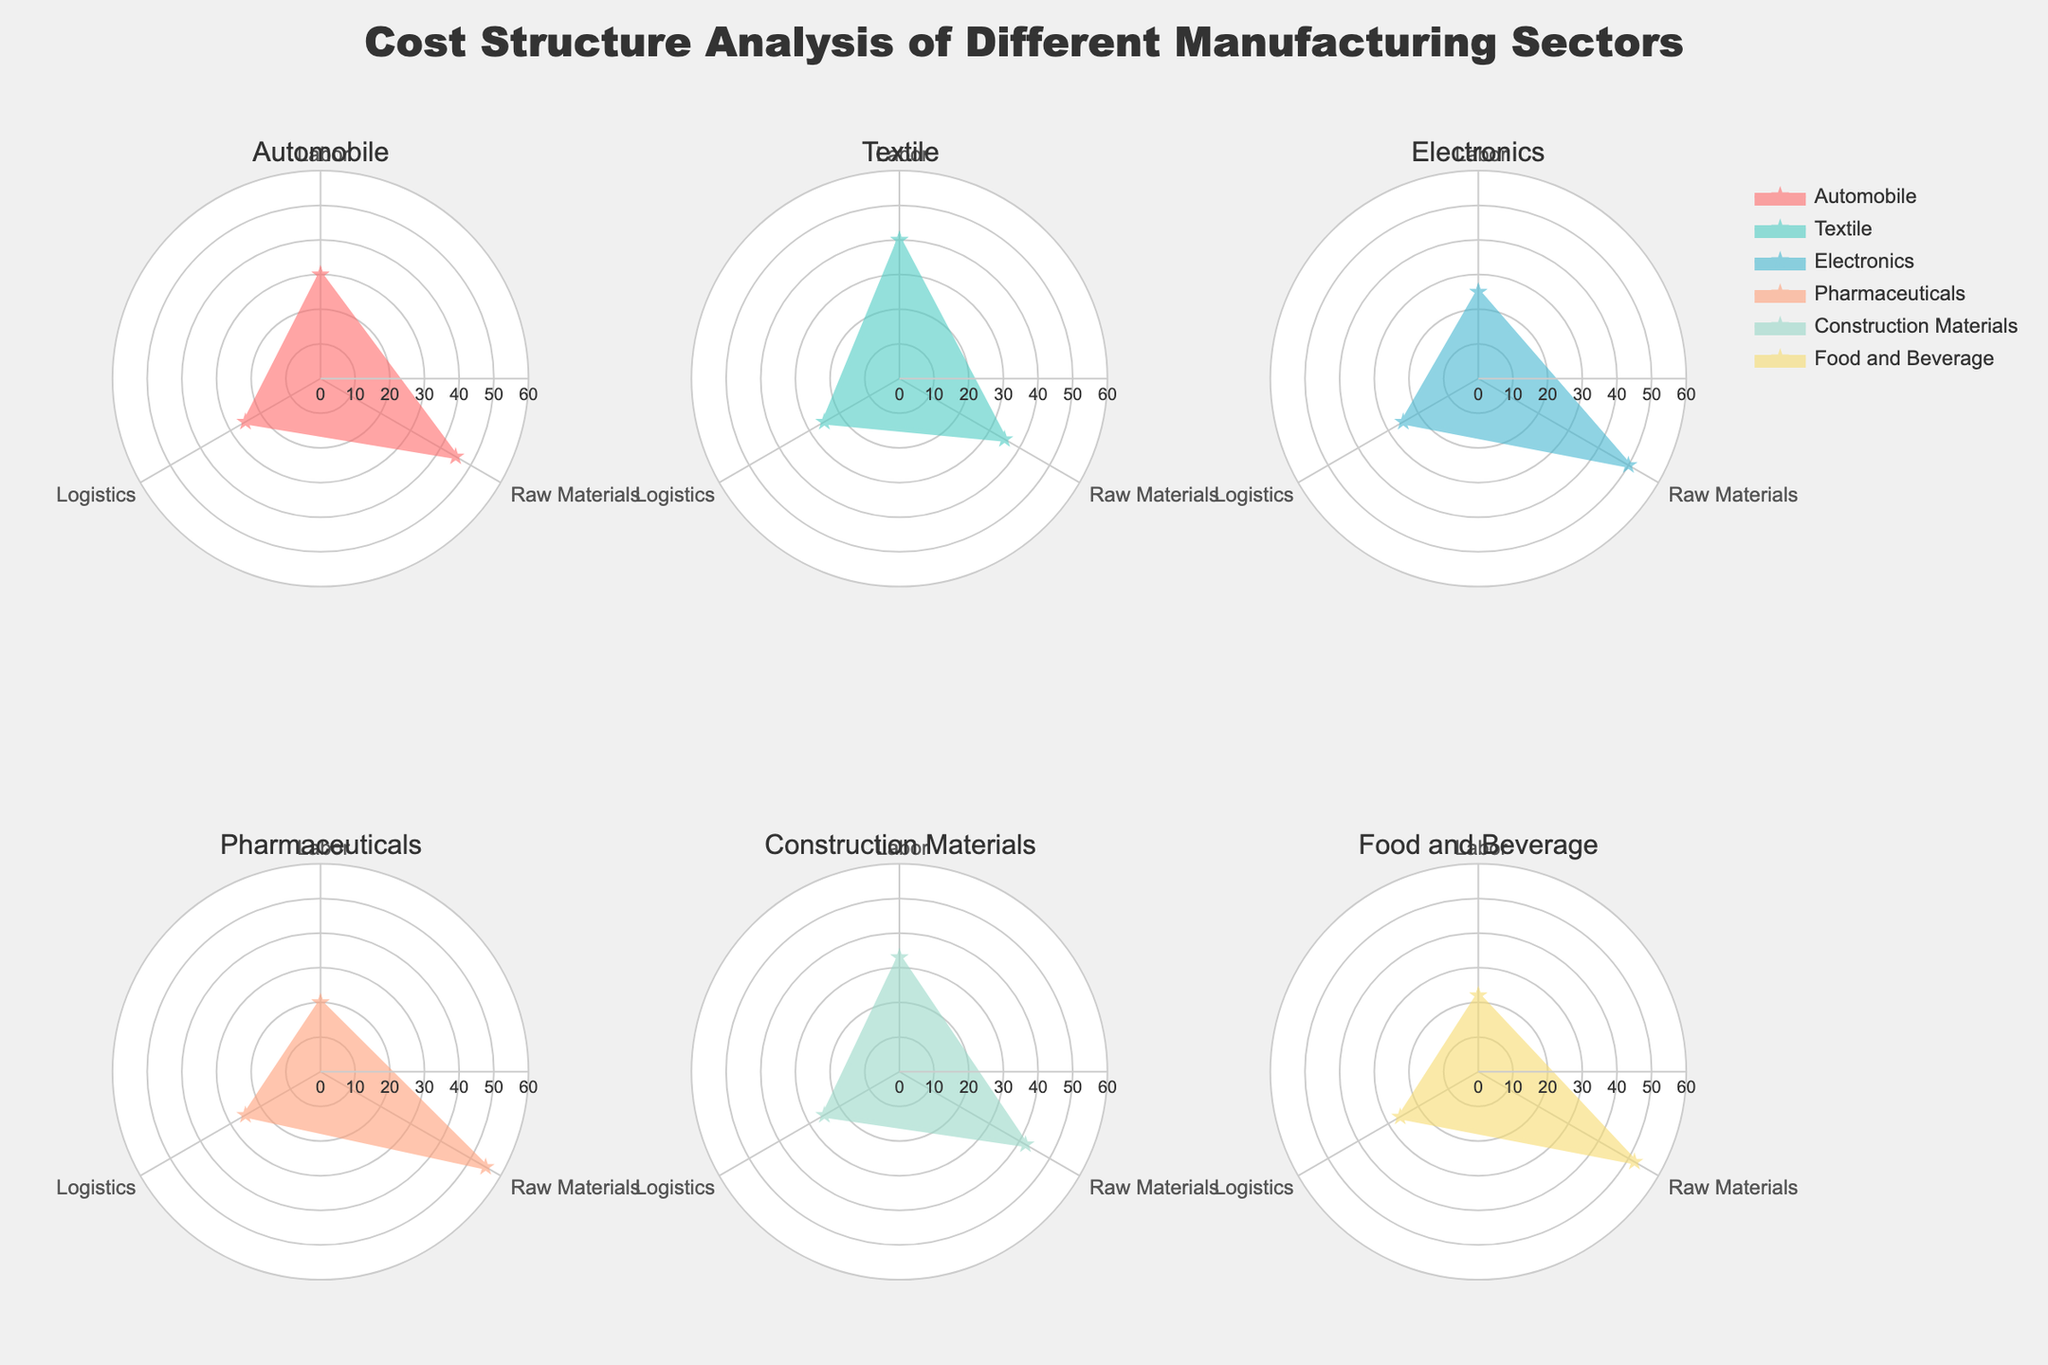Which sector has the highest cost percentage allocated to labor? By referring to the plotted data, the sector with the highest labor allocation is Textile with 40%. This can be determined by visually inspecting the labor percentage for each sector and finding the maximum value.
Answer: Textile Which two sectors have the same logistics cost percentage? By analyzing the logistics percentages in the radar charts, it can be observed that multiple sectors share the same logistics percentage. For instance, the sectors for Pharmaceuticals, Electronics, Automobile, and Textile have an identical logistics cost of 25%.
Answer: Pharmaceuticals, Electronics, Automobile, Textile What is the difference in raw material costs between Pharmaceuticals and Textile sectors? The raw material cost for Pharmaceuticals is 55%, and for Textile, it is 35%. The difference can be calculated as 55% - 35% = 20%.
Answer: 20% Which sector shows a balanced cost distribution between labor, raw materials, and logistics? By visually analyzing the radar charts for each sector, Construction Materials has a relatively balanced cost distribution with values 33% for labor, 42% for raw materials, and 25% for logistics. The values are more evenly spread compared to other sectors.
Answer: Construction Materials Rank the sectors from highest to lowest based on raw material costs. By analyzing the raw material costs from the radar charts, the ranking is as follows: Pharmaceuticals (55%), Food and Beverage (52%), Electronics (50%), Automobile (45%), Construction Materials (42%), Textile (35%).
Answer: Pharmaceuticals, Food and Beverage, Electronics, Automobile, Construction Materials, Textile Which sector has the lowest percentage allocation to labor? By inspecting the labor allocation for each sector, Pharmaceuticals has the lowest percentage at 20%.
Answer: Pharmaceuticals How does the logistics cost percentage for Construction Materials compare to the other sectors? Construction Materials has a logistics cost of 25%, which is identical to the logistics cost of several other sectors including Automobile, Textile, Electronics, and Pharmaceuticals.
Answer: Equal to Automobile, Textile, Electronics, Pharmaceuticals What is the average labor cost percentage across all sectors? Calculate the average by summing the labor percentages (30 + 40 + 25 + 20 + 33 + 22) and dividing by the number of sectors (6). This yields an average of (30 + 40 + 25 + 20 + 33 + 22) / 6 = 28.33%.
Answer: 28.33% For the sector with the highest raw material cost, how does its labor cost compare to the sector with the lowest labor cost? Pharmaceuticals has the highest raw material cost (55%), and its labor cost is 20%. Pharmaceuticals also has the lowest labor cost, so the labor cost for both criteria remains the same.
Answer: Same 